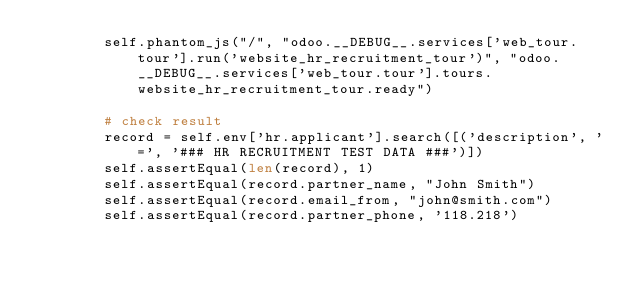Convert code to text. <code><loc_0><loc_0><loc_500><loc_500><_Python_>        self.phantom_js("/", "odoo.__DEBUG__.services['web_tour.tour'].run('website_hr_recruitment_tour')", "odoo.__DEBUG__.services['web_tour.tour'].tours.website_hr_recruitment_tour.ready")

        # check result
        record = self.env['hr.applicant'].search([('description', '=', '### HR RECRUITMENT TEST DATA ###')])
        self.assertEqual(len(record), 1)
        self.assertEqual(record.partner_name, "John Smith")
        self.assertEqual(record.email_from, "john@smith.com")
        self.assertEqual(record.partner_phone, '118.218')
</code> 